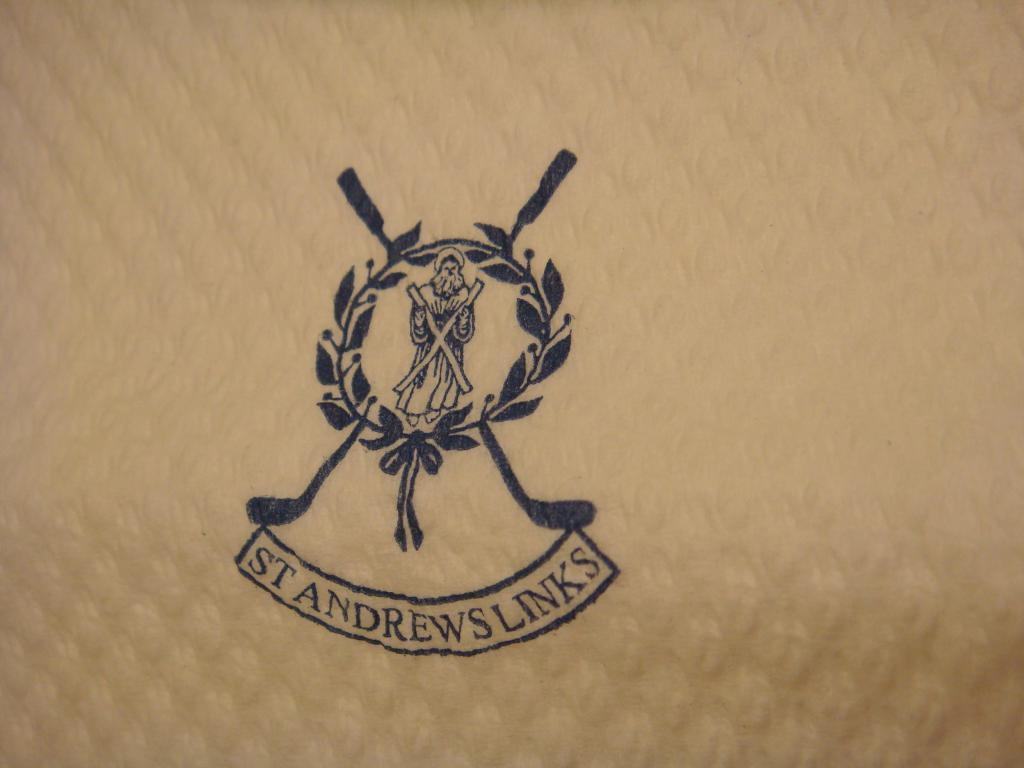What is the main subject of the image? The main subject of the image is a stamp. What is depicted on the stamp? The stamp features a person holding a cross in his hand. What text is written on the stamp? The stamp has the text "ST ANDREWS LINKS" written on it. How many crates are stacked next to the stamp in the image? There are no crates present in the image; it only features a stamp. What type of pencil is being used to write on the stamp in the image? There is no pencil present in the image; it only features a stamp. 